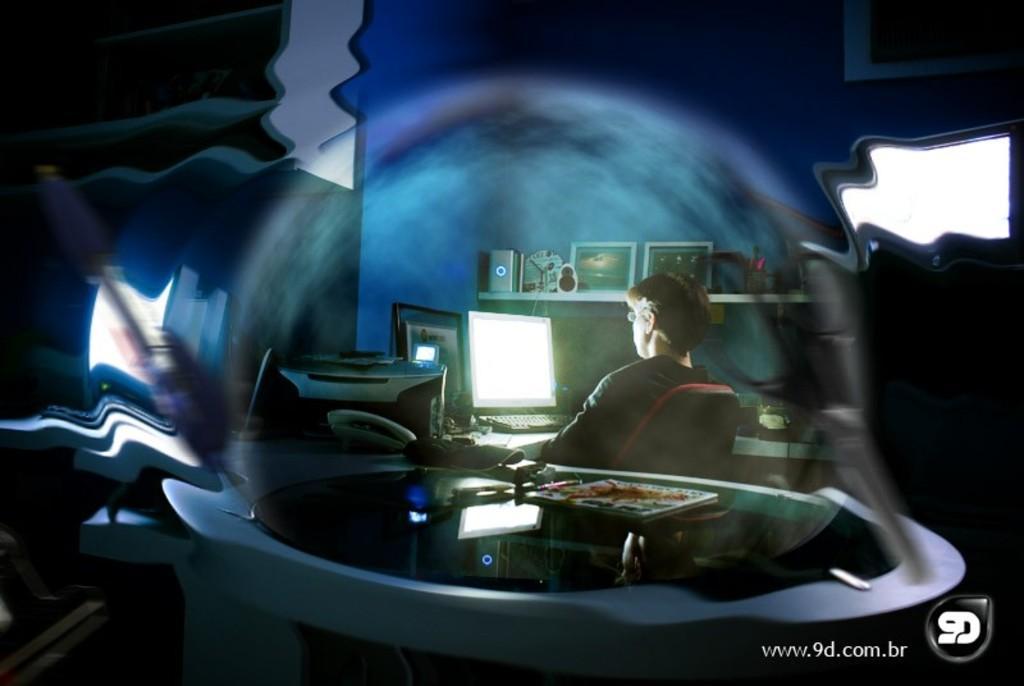Could you give a brief overview of what you see in this image? In this edited picture there is a man who is sitting on the chair near to the table. On the table I can see the computer screens, keyboard, cables, printing machine, holders and other objects. Beside him I can see the photo frames, speakers and other objects on the rack. In the bottom right corner there is a watermark. 